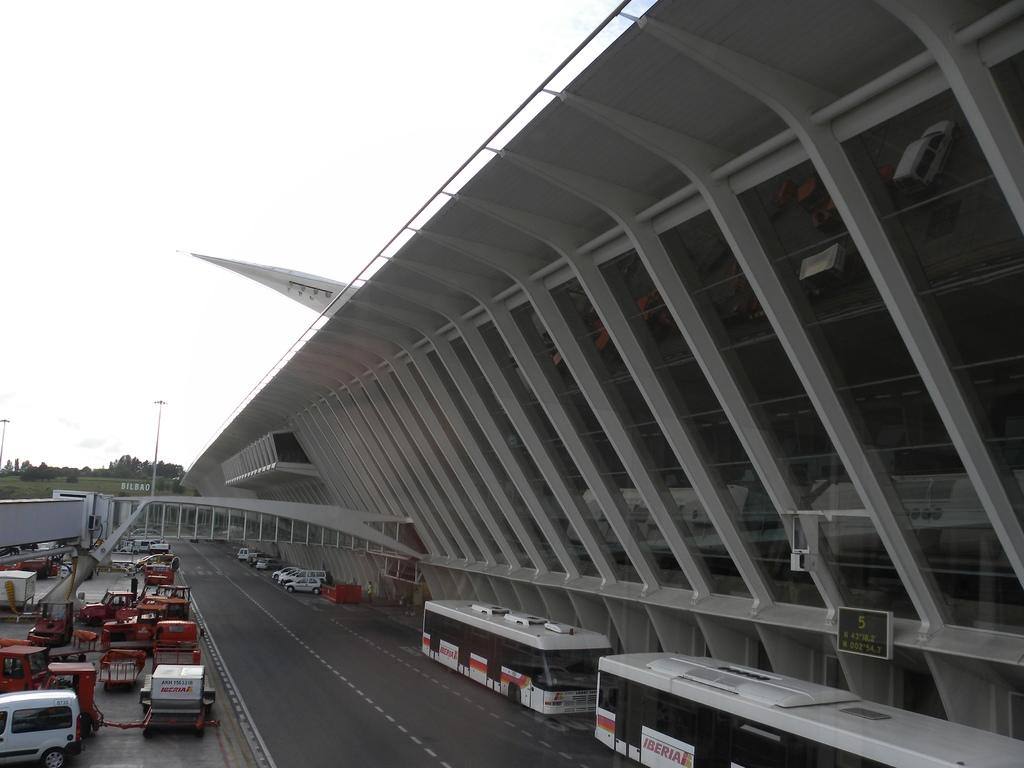What is the main feature in the middle of the image? There is a road in the middle of the image. What types of vehicles can be seen near the road? Buses and vehicles are present on either side of the road. What structure is located on the right side of the image? There is a building on the right side of the image. What part of the natural environment is visible in the image? The sky is visible above the road and the building. How many units of land can be seen on the left side of the image? There is no reference to land units in the image; it features a road, vehicles, a building, and the sky. 